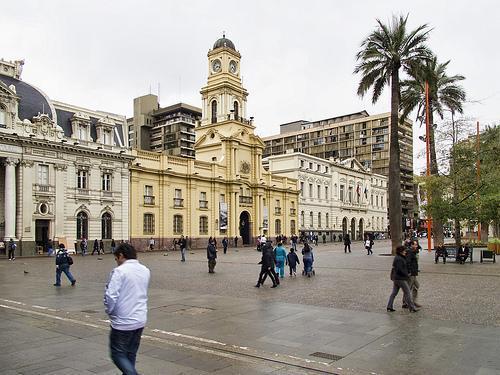How many palm trees are there?
Give a very brief answer. 2. How many people are sitting on the bench?
Give a very brief answer. 2. 